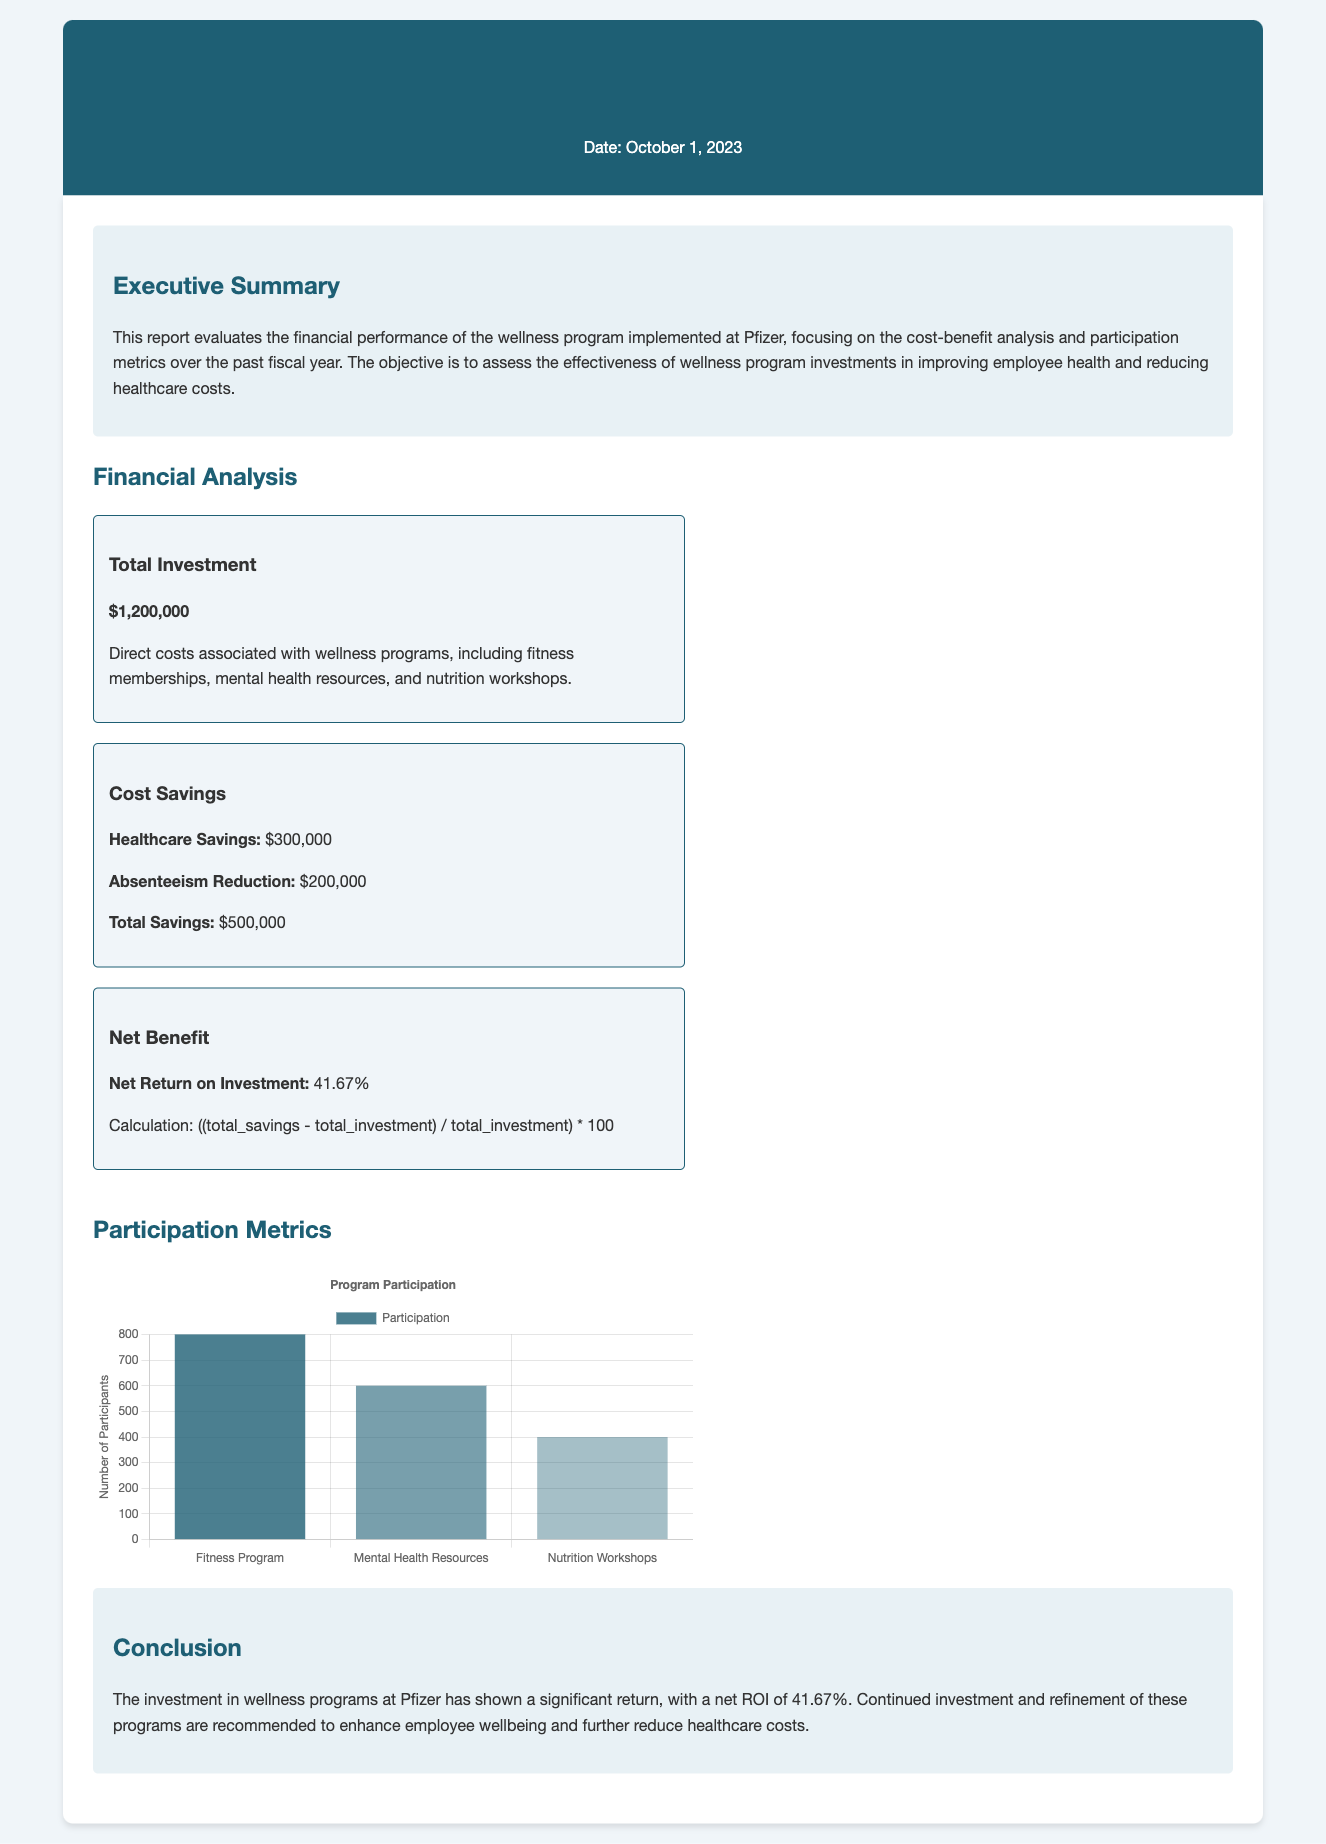What is the total investment? The total investment is explicitly stated in the financial analysis section of the document.
Answer: $1,200,000 What is the net return on investment? The net return on investment can be found in the financial analysis section, calculated based on total savings and investment.
Answer: 41.67% How much did absenteeism reduction contribute to total savings? The document specifies the contribution of absenteeism reduction to total savings in the financial analysis section.
Answer: $200,000 What is the participation number for the fitness program? The participation number is provided in the participation metrics section of the document, specifically in the chart data.
Answer: 800 Which wellness program had the lowest participation? The lowest participation is indicated in the participation metrics section by comparing the numbers provided for each program.
Answer: Nutrition Workshops What is the total savings from healthcare? The total savings from healthcare is mentioned in the financial analysis section as part of the overall savings breakdown.
Answer: $300,000 What date is the report published? The date of publication is stated at the top of the document, right after the title.
Answer: October 1, 2023 What are the key components of the total investment? The document describes the direct costs associated with wellness programs, which are the components of total investment.
Answer: Fitness memberships, mental health resources, nutrition workshops What does the conclusion recommend? The conclusion summarizes the findings and implies a recommendation based on the financial performance analysis.
Answer: Continued investment and refinement of programs 